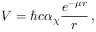Convert formula to latex. <formula><loc_0><loc_0><loc_500><loc_500>V = \hbar { c } \alpha _ { \chi } \frac { e ^ { - \mu r } } { r } \, ,</formula> 